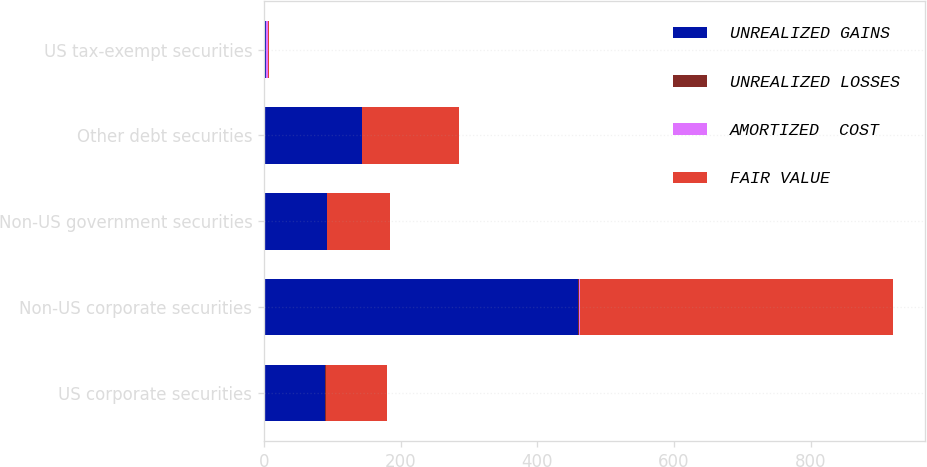<chart> <loc_0><loc_0><loc_500><loc_500><stacked_bar_chart><ecel><fcel>US corporate securities<fcel>Non-US corporate securities<fcel>Non-US government securities<fcel>Other debt securities<fcel>US tax-exempt securities<nl><fcel>UNREALIZED GAINS<fcel>89.7<fcel>459.4<fcel>91.5<fcel>142.8<fcel>2.25<nl><fcel>UNREALIZED LOSSES<fcel>0.2<fcel>1.3<fcel>0.3<fcel>0.1<fcel>0.2<nl><fcel>AMORTIZED  COST<fcel>0.2<fcel>1.4<fcel>0.1<fcel>0.7<fcel>3.1<nl><fcel>FAIR VALUE<fcel>89.7<fcel>459.3<fcel>91.7<fcel>142.2<fcel>2.25<nl></chart> 